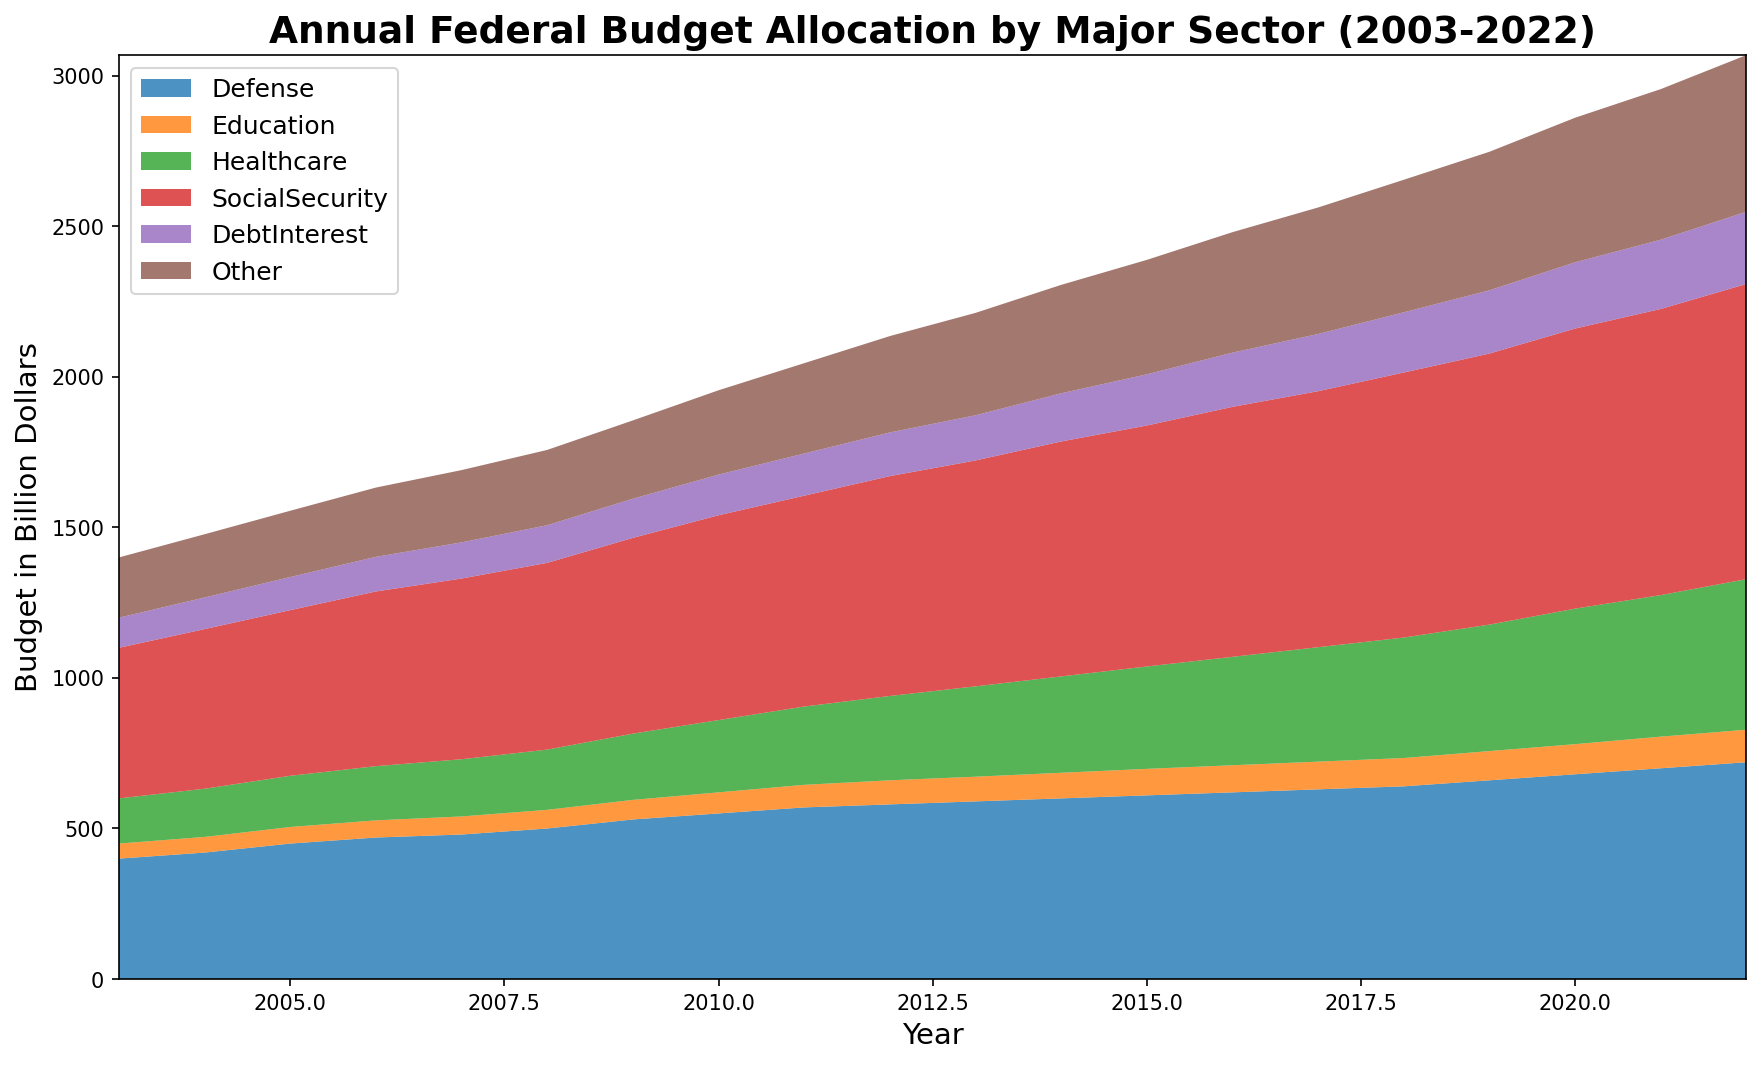Which sector received the highest budget allocation in 2022? By looking at the chart for the year 2022, identify the area with the largest size. SocialSecurity shows the largest area in the chart.
Answer: SocialSecurity How did the budget for Education change from 2003 to 2022? Compare the heights of the Education section between 2003 and 2022. The Education budget increased from 50 billion dollars in 2003 to 108 billion dollars in 2022.
Answer: Increased Which sector had a higher budget in 2010: Defense or Healthcare? Compare the heights of areas for Defense and Healthcare in the year 2010. Defense's height is larger than Healthcare's height.
Answer: Defense What is the total budget allocation for DebtInterest over the last decade (2013-2022)? Identify the DebtInterest values from 2013 to 2022 and sum them up: 150+160+170+180+190+200+210+220+230+240 = 1950 billion dollars.
Answer: 1950 billion dollars How does the growth rate of the Healthcare budget between 2003 and 2022 compare with Defense growth rate over the same period? Find the initial and final values for both sectors: Healthcare (150 in 2003, 500 in 2022), Defense (400 in 2003, 720 in 2022). Calculate the growth rates: Healthcare = (500-150)/150 = 2.33 or 233%, Defense = (720-400)/400 = 0.8 or 80%.
Answer: Healthcare grew faster Which two sectors showed the most stability (least fluctuation) over the last two decades? Look for areas where the height changed the least over the years. DebtInterest and SocialSecurity areas appeared fairly stable compared to others.
Answer: DebtInterest and SocialSecurity In which year did the Healthcare budget surpass the Defense budget for the first time? Identify the year from the chart where the Healthcare area's height surpasses the Defense area. This event does not occur within the provided years as Defense always remains higher.
Answer: Never How much did the budget for Other change between 2003 and 2022? Compare the values for Other in 2003 and 2022: 200 billion dollars in 2003 and 520 billion dollars in 2022. So, the change is 520-200 = 320 billion dollars.
Answer: 320 billion dollars What was the approximate total federal budget in 2008? Sum the values for all sectors in 2008: 500+62+200+620+125+250 = 1757 billion dollars.
Answer: 1757 billion dollars Did any sector's budget decrease at any point during the last two decades? Examining each sector trend lines year by year, none of the sectors show a decline at any point; all sectors show continuous increase.
Answer: No 